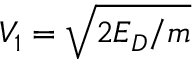Convert formula to latex. <formula><loc_0><loc_0><loc_500><loc_500>V _ { 1 } = \sqrt { 2 E _ { D } / m }</formula> 